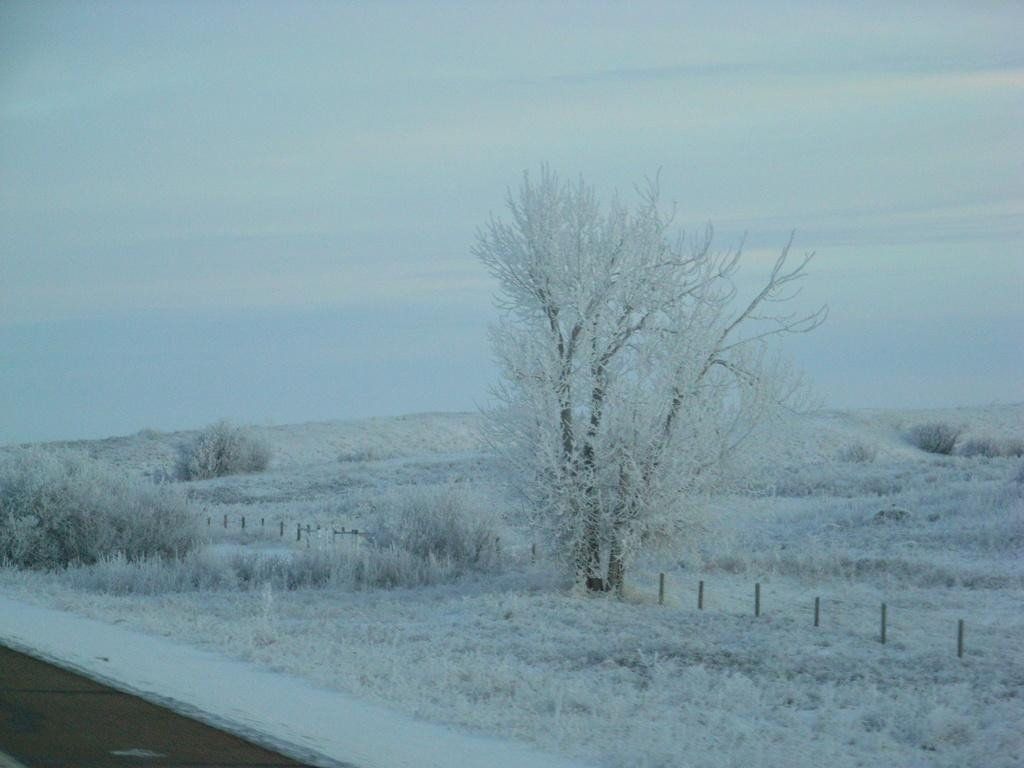What type of surface is visible in the image? There is a grass surface in the image. What other natural elements can be seen in the image? There are plants and trees in the image. What is visible in the background of the image? The sky is visible in the background of the image. Can you describe the sky in the image? Clouds are present in the sky. Who is the creator of the dock in the image? There is no dock present in the image, so it is not possible to determine who the creator might be. 